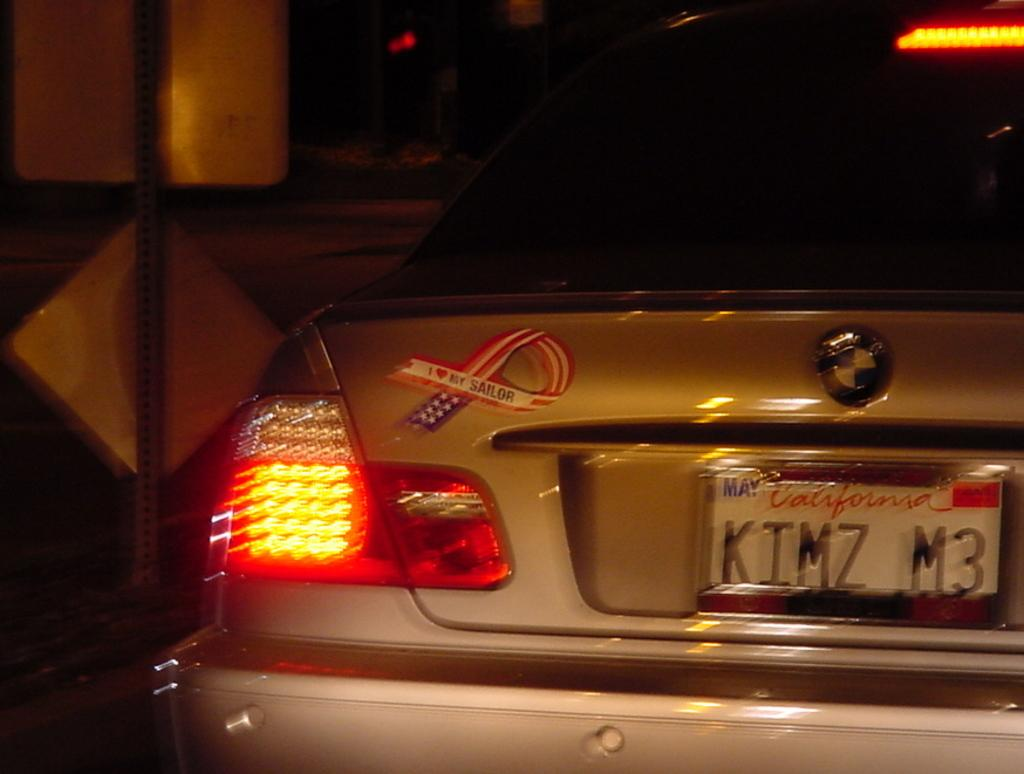<image>
Give a short and clear explanation of the subsequent image. A silver BMW has a California plate that reads "KIMZ M3." 